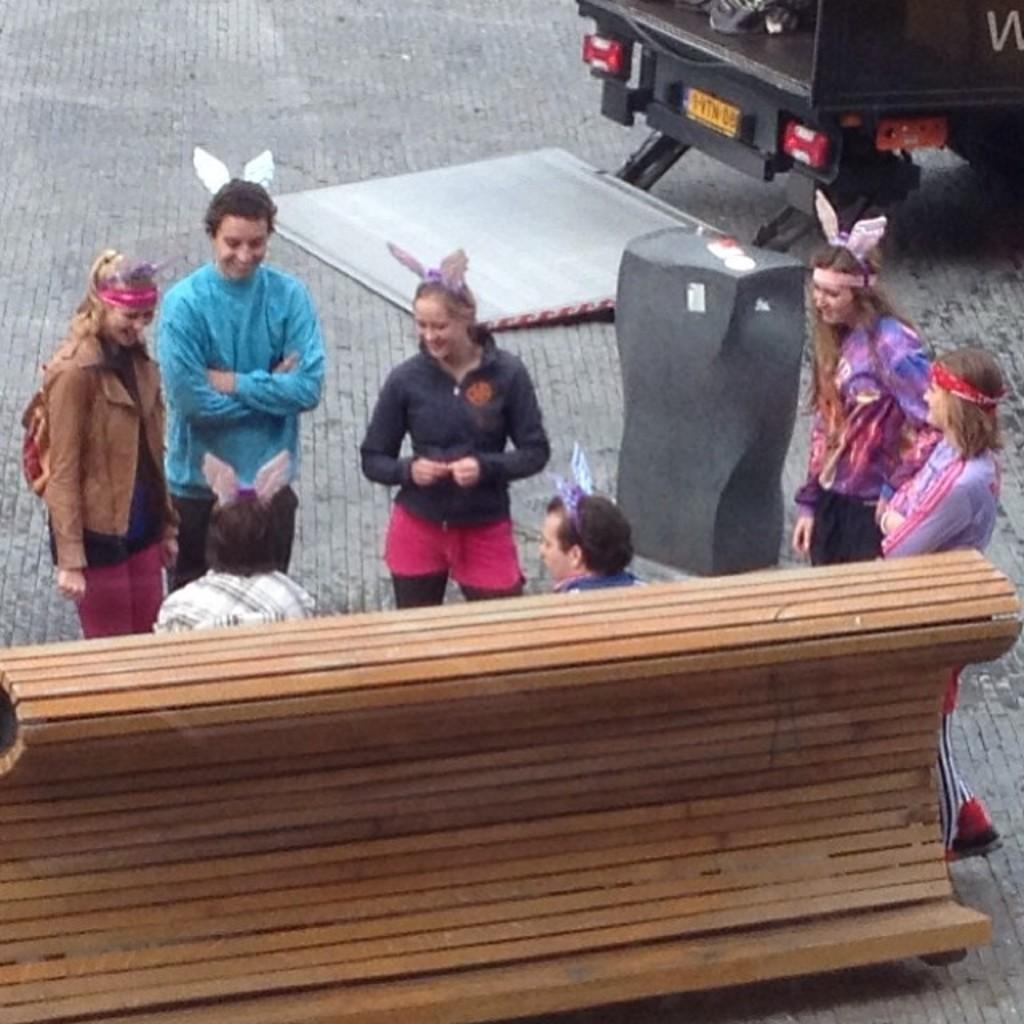Describe this image in one or two sentences. In this image we can see these two people are sitting on the wooden bench and these people are standing near them. In the background, we can see a vehicle on the road. 